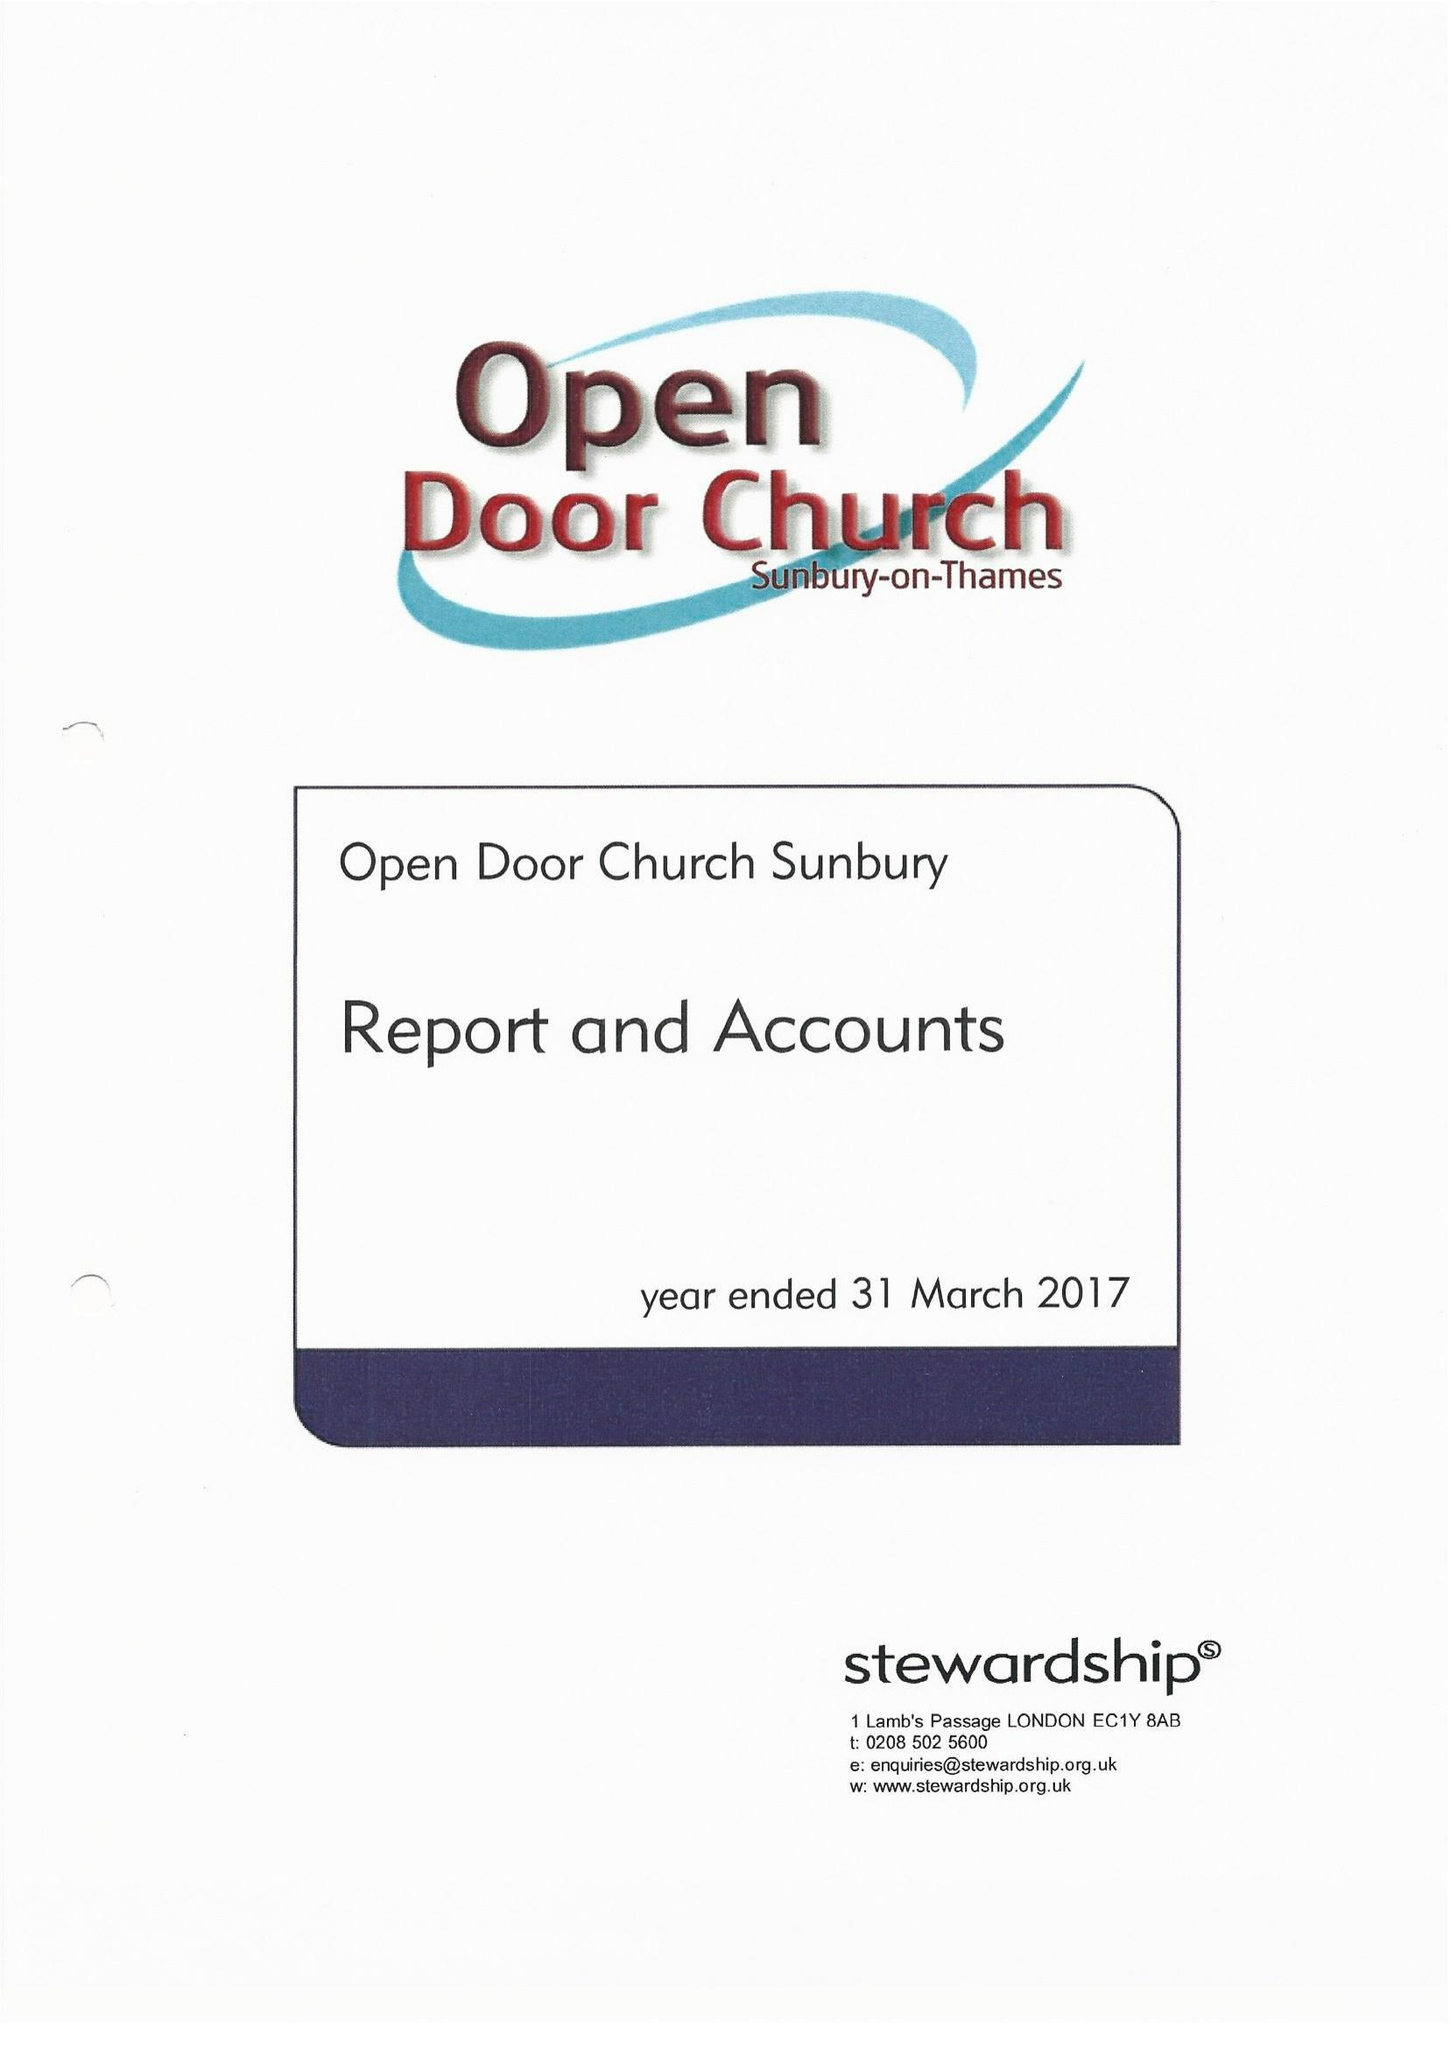What is the value for the address__post_town?
Answer the question using a single word or phrase. SUNBURY-ON-THAMES 